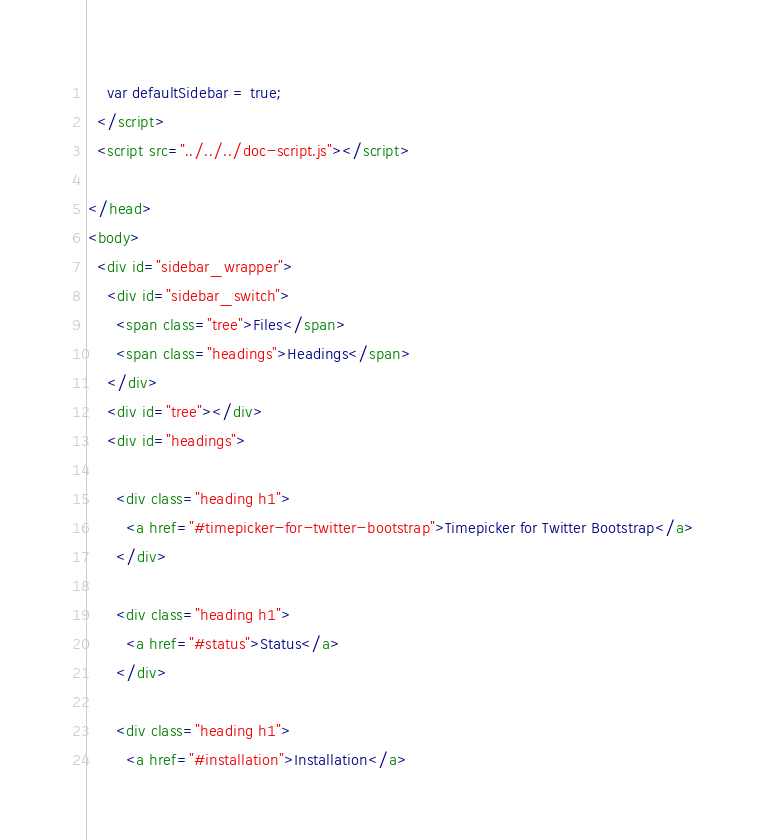Convert code to text. <code><loc_0><loc_0><loc_500><loc_500><_HTML_>    var defaultSidebar = true;
  </script>
  <script src="../../../doc-script.js"></script>

</head>
<body>
  <div id="sidebar_wrapper">
    <div id="sidebar_switch">
      <span class="tree">Files</span>
      <span class="headings">Headings</span>
    </div>
    <div id="tree"></div>
    <div id="headings">

      <div class="heading h1">
        <a href="#timepicker-for-twitter-bootstrap">Timepicker for Twitter Bootstrap</a>
      </div>

      <div class="heading h1">
        <a href="#status">Status</a>
      </div>

      <div class="heading h1">
        <a href="#installation">Installation</a></code> 